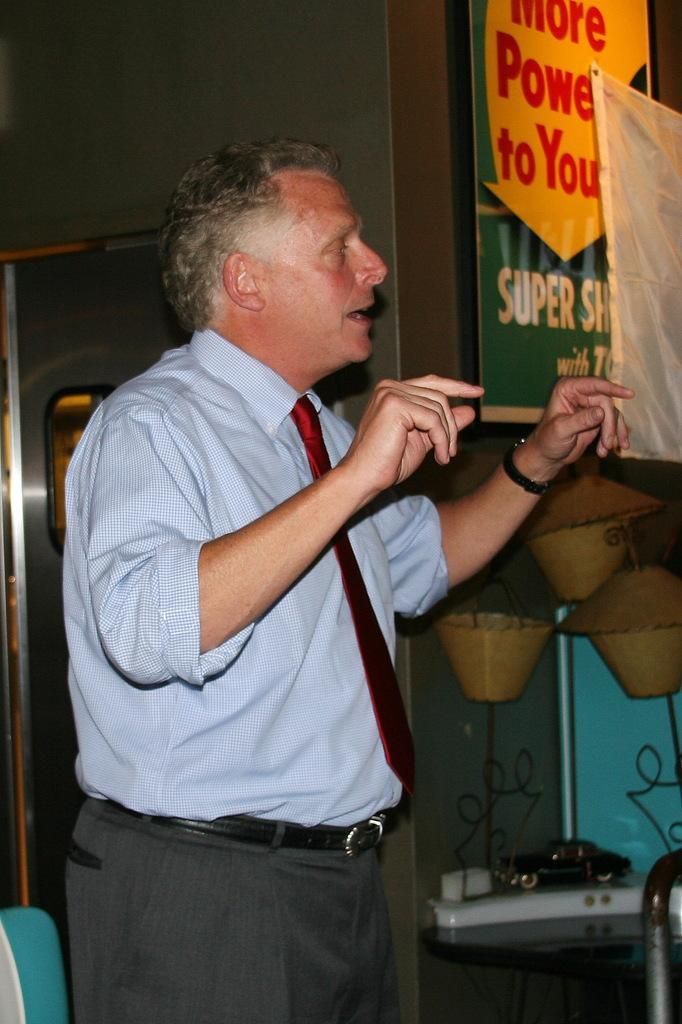<image>
Share a concise interpretation of the image provided. man speaking in front of a banner that says "More Power To You". 